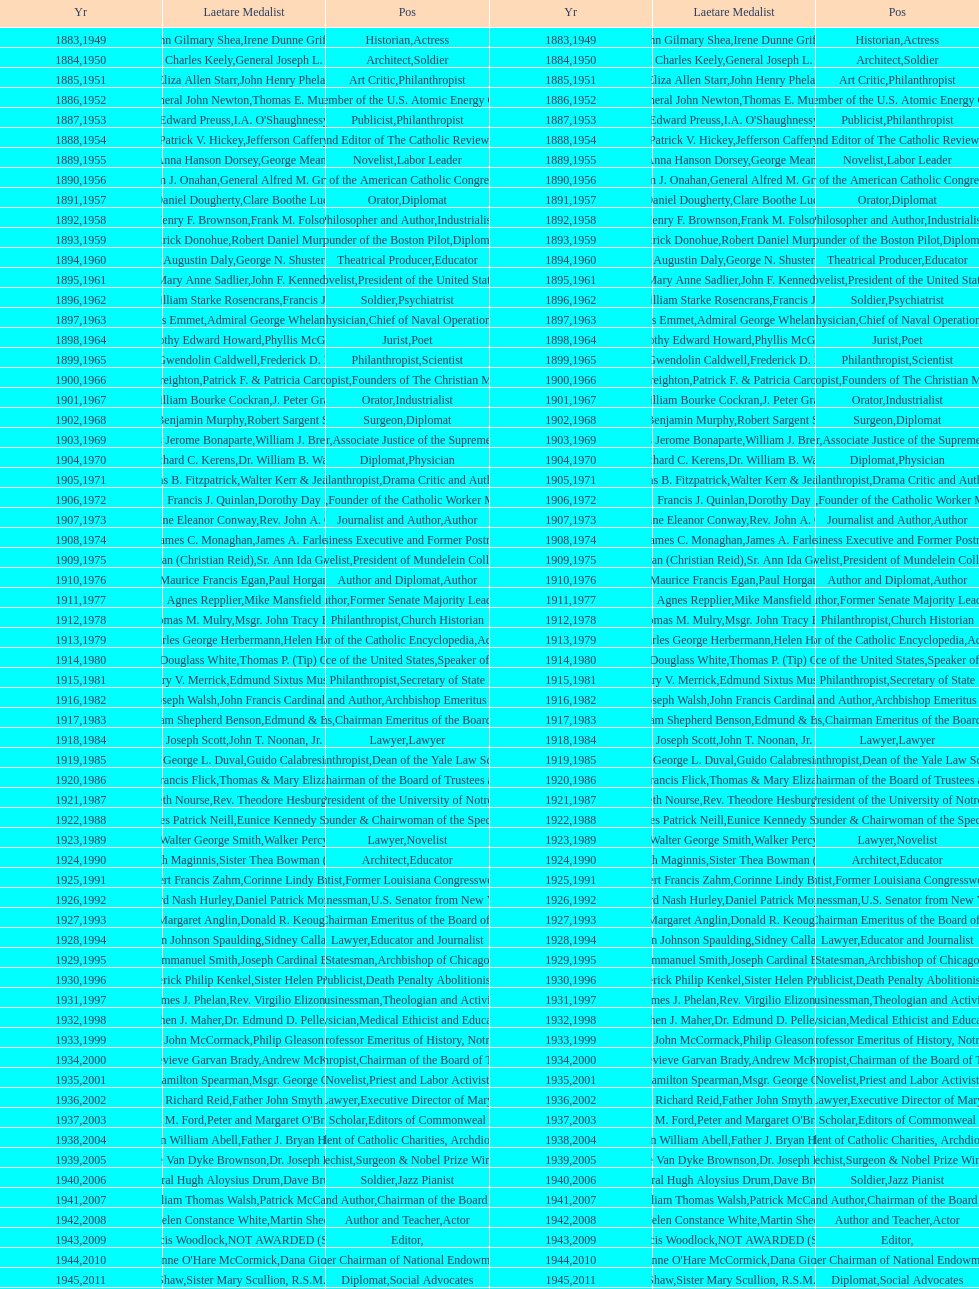How many counsel have been given the award from 1883 to 2014? 5. 